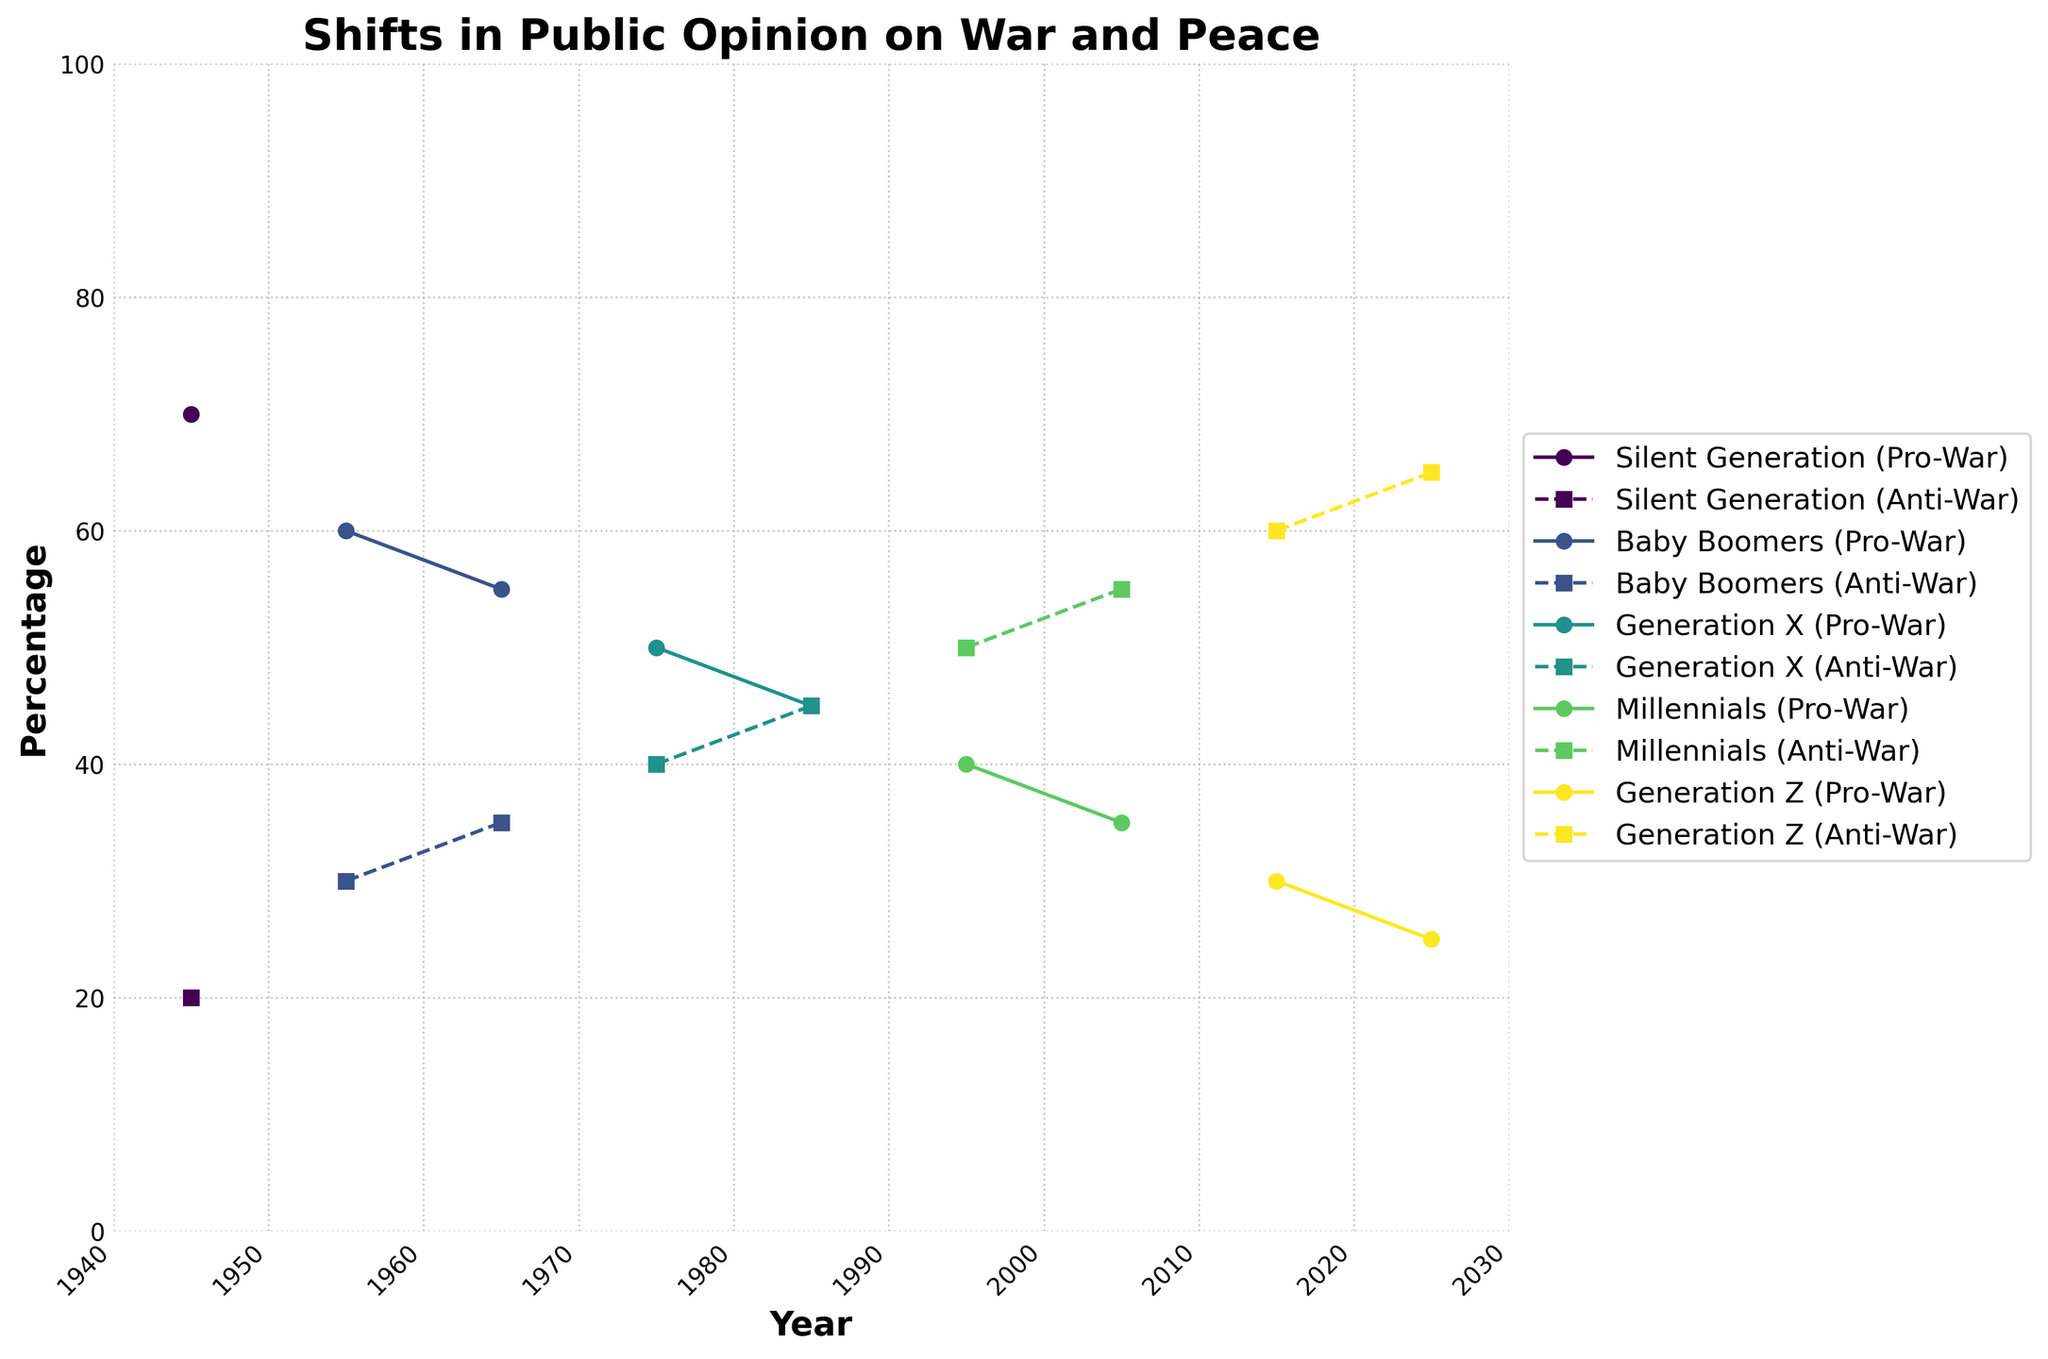What is the title of the figure? The title of the figure is displayed at the top of the plot. It reads "Shifts in Public Opinion on War and Peace".
Answer: Shifts in Public Opinion on War and Peace Which generation has the highest Pro-War percentage in 1945? By looking at the plot, the Silent Generation in 1945 has the highest Pro-War percentage, marked at 70%.
Answer: Silent Generation How does the Pro-War opinion trend for Millennials from 1995 to 2005? The plot shows the Pro-War percentages for Millennials at 1995 and 2005, with values at 40% and 35% respectively, indicating a decreasing trend.
Answer: Decreasing What is the difference in Anti-War percentage between Generation X in 1985 and Generation Z in 2025? From the plot, Generation X in 1985 has an Anti-War percentage of 45%, and Generation Z in 2025 has 65%. The difference is 65 - 45 = 20.
Answer: 20 During which year did Generation X first see their Anti-War sentiment surpass their Pro-War sentiment? By reviewing the plot, Generation X’s Anti-War sentiment surpasses their Pro-War sentiment in 1985 when both values are equal at 45%.
Answer: 1985 Which generation shows the sharpest increase in Anti-War sentiment over the given years? Comparing the slopes of the Anti-War lines across generations, Generation Z shows the sharpest increase from 60% in 2015 to 65% in 2025.
Answer: Generation Z What is the average Pro-War percentage for the Baby Boomers from 1955 to 1965? From the plot, the Pro-War percentages for Baby Boomers in 1955 and 1965 are 60% and 55%. The average is (60 + 55) / 2 = 57.5%.
Answer: 57.5% Which generation had a consistent Pro-War percentage from 1945 to 2025? No generation shows a completely consistent Pro-War percentage over the entire timespan; all lines show some degree of change.
Answer: None How many distinct generations are shown in the plot? By looking at the legend of the plot, there are four distinct generations: Silent Generation, Baby Boomers, Generation X, Millennials, and Generation Z.
Answer: 4 Which generation had the lowest Pro-War percentage in 2025? From the plot, Generation Z had the lowest Pro-War percentage at 25% in 2025.
Answer: Generation Z 